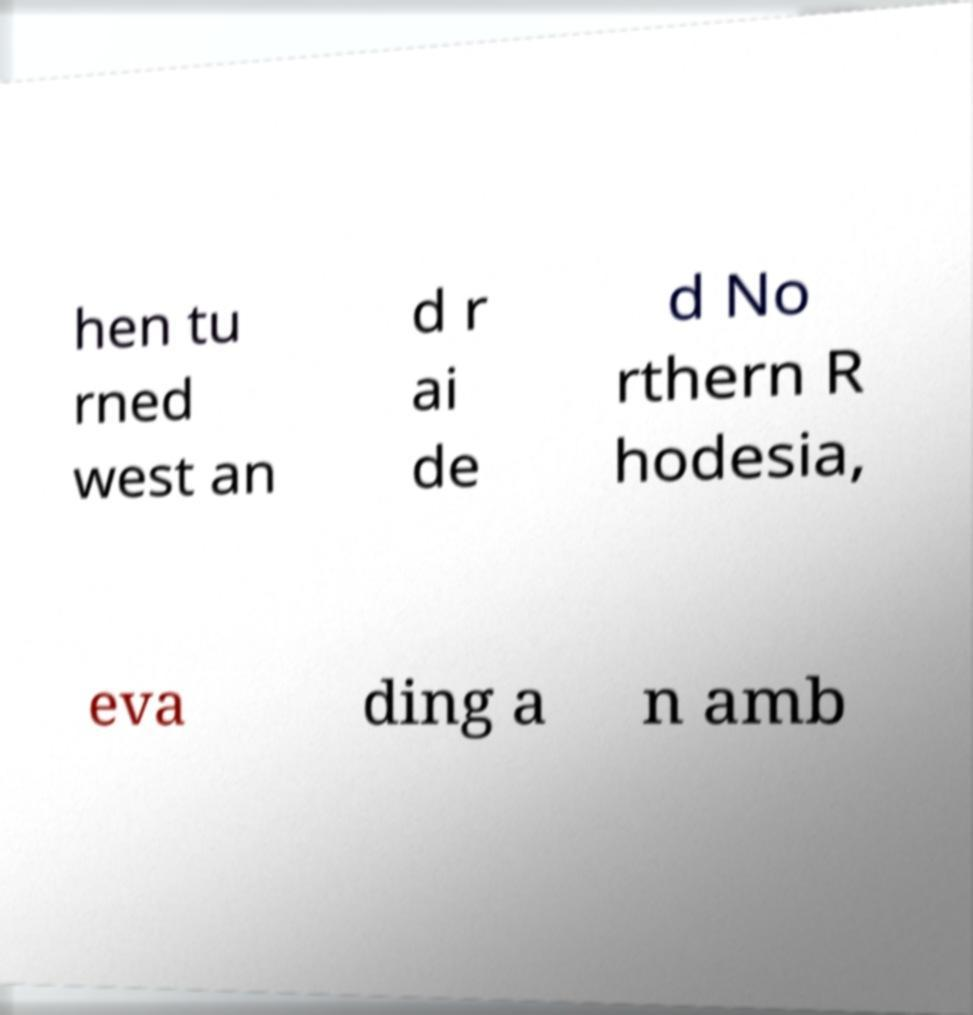Please identify and transcribe the text found in this image. hen tu rned west an d r ai de d No rthern R hodesia, eva ding a n amb 